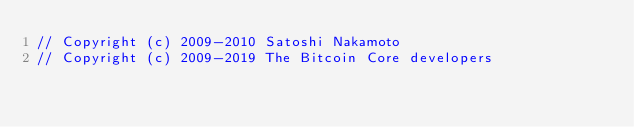Convert code to text. <code><loc_0><loc_0><loc_500><loc_500><_C_>// Copyright (c) 2009-2010 Satoshi Nakamoto
// Copyright (c) 2009-2019 The Bitcoin Core developers</code> 